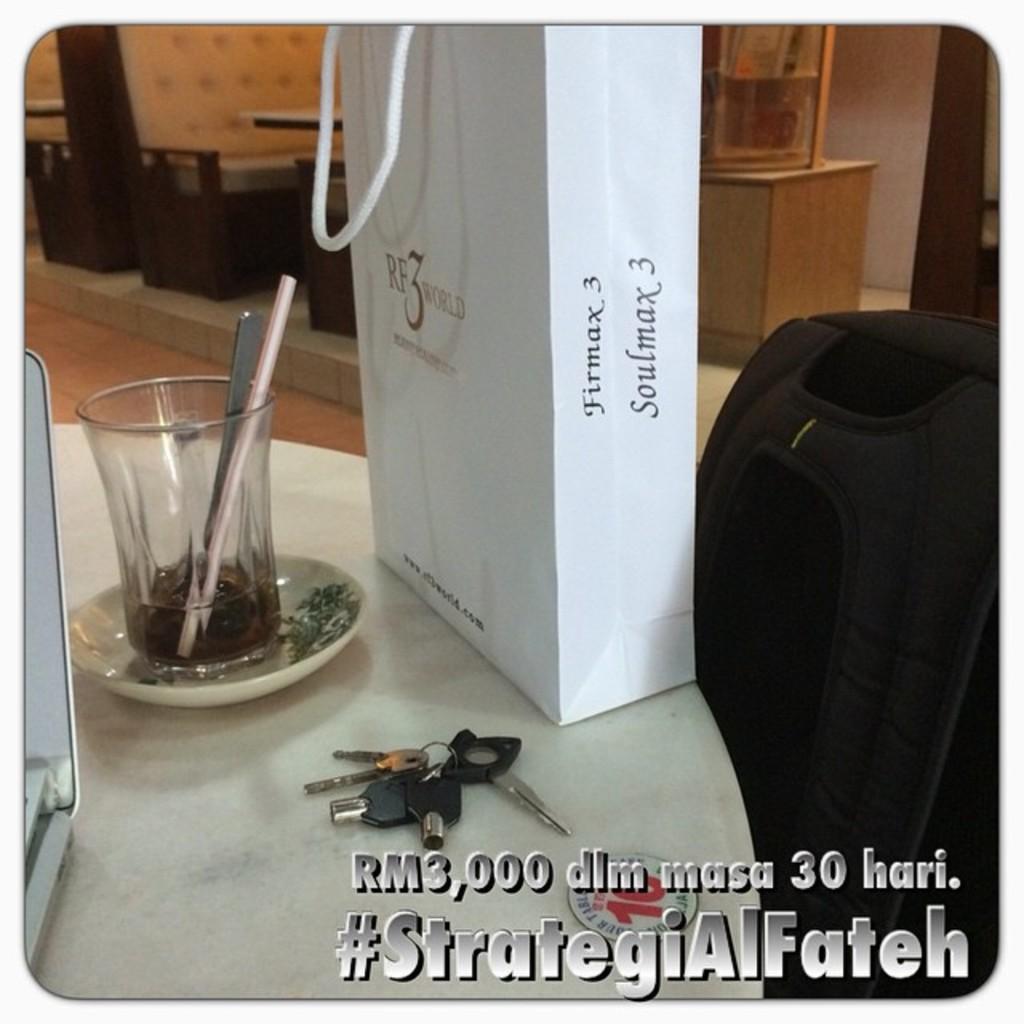What does the text say in grey?
Make the answer very short. Strategialfateh. Some product in the glass?
Provide a short and direct response. Yes. 